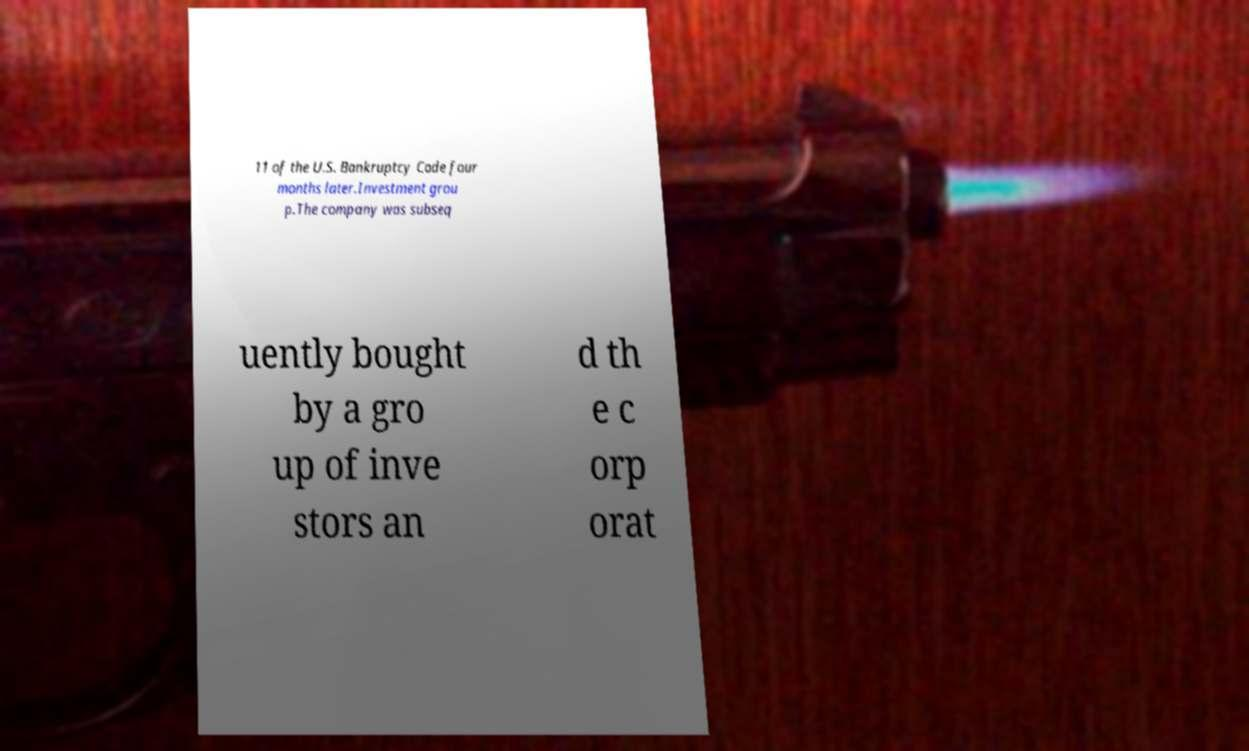Could you assist in decoding the text presented in this image and type it out clearly? 11 of the U.S. Bankruptcy Code four months later.Investment grou p.The company was subseq uently bought by a gro up of inve stors an d th e c orp orat 